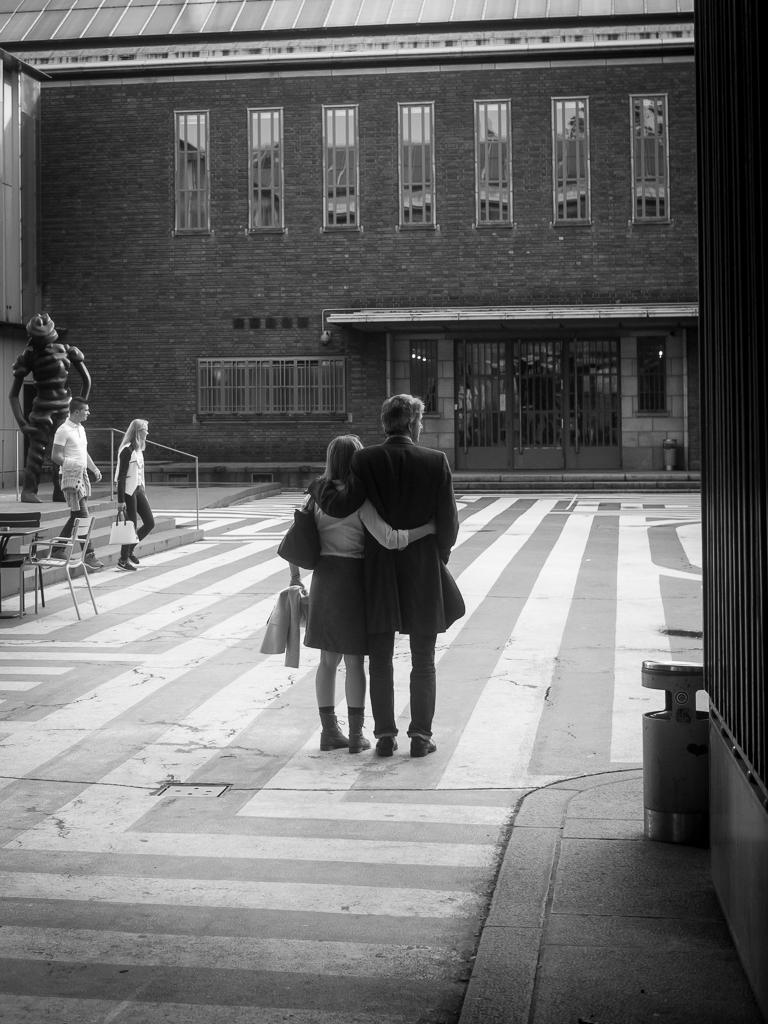How many people are in the image? There are people in the image, but the exact number is not specified. What are some people holding in the image? Some people are holding objects in the image. What can be seen under the people's feet in the image? The ground is visible in the image. What type of furniture is present in the image? Chairs are present in the image. What type of container is present in the image? A dustbin is present in the image. What type of structures are visible in the background of the image? Buildings are visible in the image. What type of doors are visible in the image? Glass doors are visible in the image. What type of architectural feature is present in the image? Stairs are present in the image. How many tomatoes are being held by the boys in the image? There is no mention of tomatoes or boys in the image, so it is not possible to answer this question. 